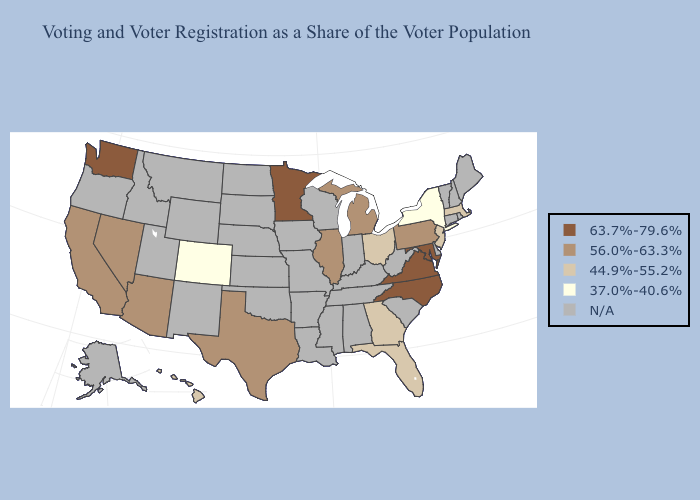What is the highest value in the West ?
Quick response, please. 63.7%-79.6%. What is the lowest value in the South?
Write a very short answer. 44.9%-55.2%. Does Illinois have the lowest value in the USA?
Concise answer only. No. Name the states that have a value in the range 63.7%-79.6%?
Quick response, please. Maryland, Minnesota, North Carolina, Virginia, Washington. Name the states that have a value in the range N/A?
Short answer required. Alabama, Alaska, Arkansas, Connecticut, Delaware, Idaho, Indiana, Iowa, Kansas, Kentucky, Louisiana, Maine, Mississippi, Missouri, Montana, Nebraska, New Hampshire, New Mexico, North Dakota, Oklahoma, Oregon, Rhode Island, South Carolina, South Dakota, Tennessee, Utah, Vermont, West Virginia, Wisconsin, Wyoming. What is the value of Louisiana?
Short answer required. N/A. Does Georgia have the highest value in the South?
Quick response, please. No. What is the value of New York?
Keep it brief. 37.0%-40.6%. What is the highest value in states that border Connecticut?
Keep it brief. 44.9%-55.2%. What is the highest value in the South ?
Quick response, please. 63.7%-79.6%. 